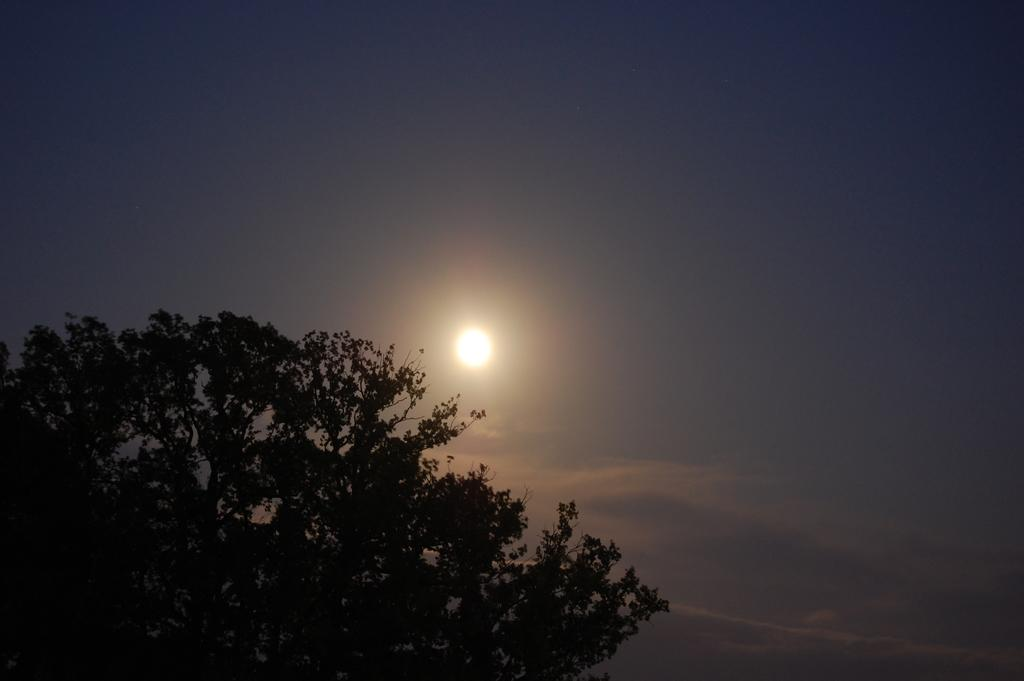What type of natural element can be seen in the image? There is a tree in the image. What celestial body is visible in the sky in the image? The moon is visible in the sky in the image. What type of quiver can be seen hanging from the tree in the image? There is no quiver present in the image; it only features a tree and the moon in the sky. 